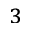Convert formula to latex. <formula><loc_0><loc_0><loc_500><loc_500>^ { 3 }</formula> 